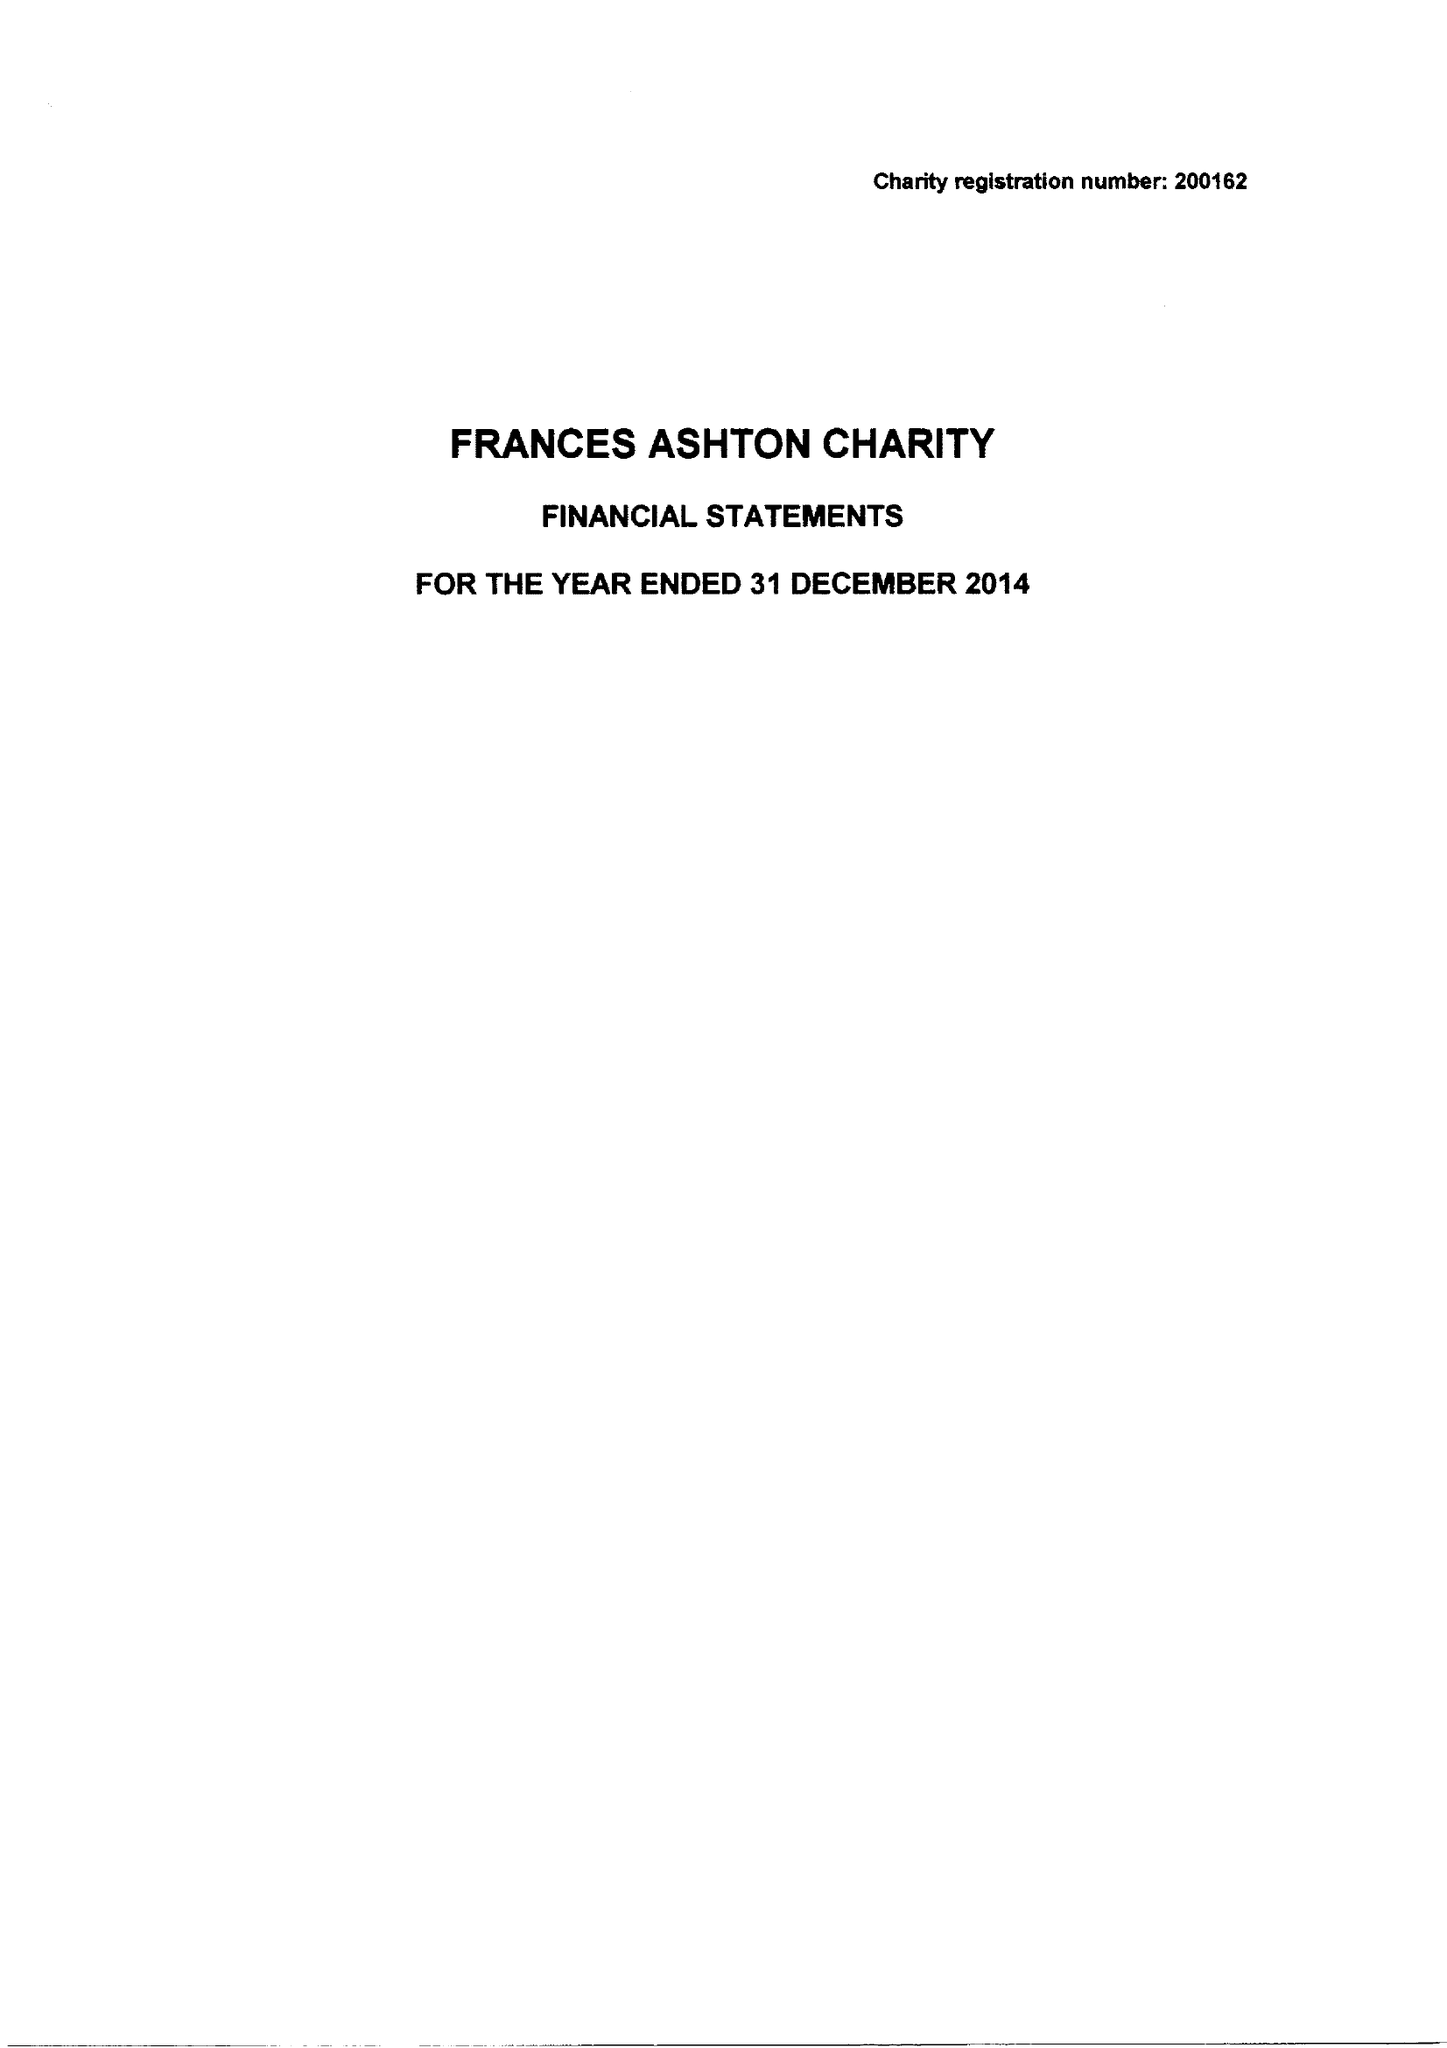What is the value for the report_date?
Answer the question using a single word or phrase. 2014-12-31 